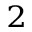<formula> <loc_0><loc_0><loc_500><loc_500>^ { 2 }</formula> 